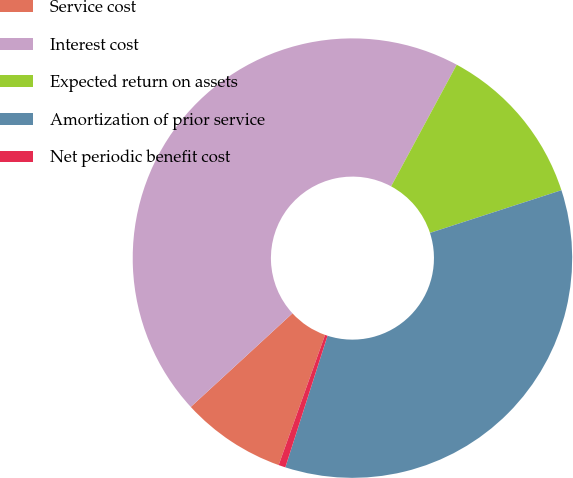<chart> <loc_0><loc_0><loc_500><loc_500><pie_chart><fcel>Service cost<fcel>Interest cost<fcel>Expected return on assets<fcel>Amortization of prior service<fcel>Net periodic benefit cost<nl><fcel>7.71%<fcel>44.71%<fcel>12.13%<fcel>34.94%<fcel>0.51%<nl></chart> 